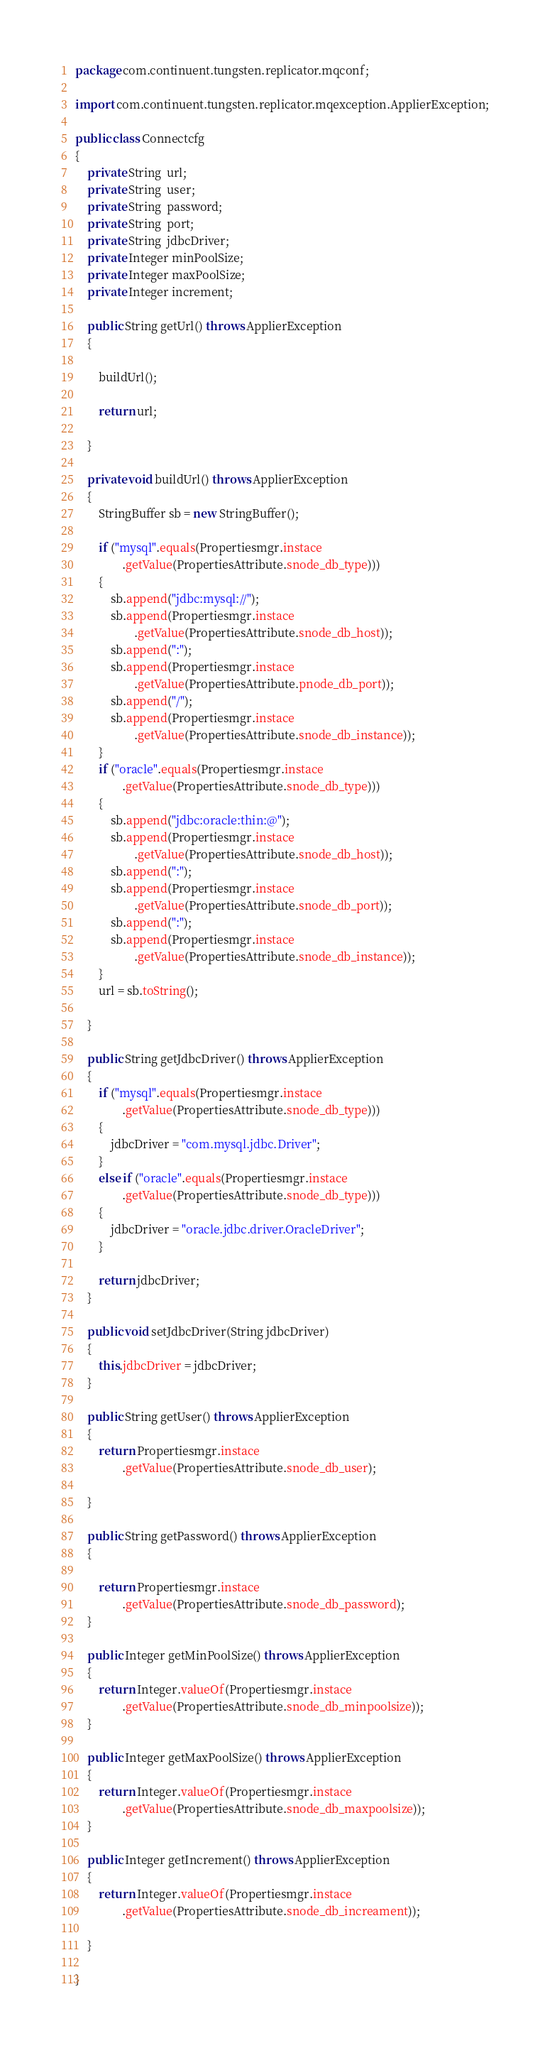Convert code to text. <code><loc_0><loc_0><loc_500><loc_500><_Java_>
package com.continuent.tungsten.replicator.mqconf;

import com.continuent.tungsten.replicator.mqexception.ApplierException;

public class Connectcfg
{
    private String  url;
    private String  user;
    private String  password;
    private String  port;
    private String  jdbcDriver;
    private Integer minPoolSize;
    private Integer maxPoolSize;
    private Integer increment;

    public String getUrl() throws ApplierException
    {

        buildUrl();

        return url;

    }

    private void buildUrl() throws ApplierException
    {
        StringBuffer sb = new StringBuffer();

        if ("mysql".equals(Propertiesmgr.instace
                .getValue(PropertiesAttribute.snode_db_type)))
        {
            sb.append("jdbc:mysql://");
            sb.append(Propertiesmgr.instace
                    .getValue(PropertiesAttribute.snode_db_host));
            sb.append(":");
            sb.append(Propertiesmgr.instace
                    .getValue(PropertiesAttribute.pnode_db_port));
            sb.append("/");
            sb.append(Propertiesmgr.instace
                    .getValue(PropertiesAttribute.snode_db_instance));
        }
        if ("oracle".equals(Propertiesmgr.instace
                .getValue(PropertiesAttribute.snode_db_type)))
        {
            sb.append("jdbc:oracle:thin:@");
            sb.append(Propertiesmgr.instace
                    .getValue(PropertiesAttribute.snode_db_host));
            sb.append(":");
            sb.append(Propertiesmgr.instace
                    .getValue(PropertiesAttribute.snode_db_port));
            sb.append(":");
            sb.append(Propertiesmgr.instace
                    .getValue(PropertiesAttribute.snode_db_instance));
        }
        url = sb.toString();

    }

    public String getJdbcDriver() throws ApplierException
    {
        if ("mysql".equals(Propertiesmgr.instace
                .getValue(PropertiesAttribute.snode_db_type)))
        {
            jdbcDriver = "com.mysql.jdbc.Driver";
        }
        else if ("oracle".equals(Propertiesmgr.instace
                .getValue(PropertiesAttribute.snode_db_type)))
        {
            jdbcDriver = "oracle.jdbc.driver.OracleDriver";
        }

        return jdbcDriver;
    }

    public void setJdbcDriver(String jdbcDriver)
    {
        this.jdbcDriver = jdbcDriver;
    }

    public String getUser() throws ApplierException
    {
        return Propertiesmgr.instace
                .getValue(PropertiesAttribute.snode_db_user);

    }

    public String getPassword() throws ApplierException
    {

        return Propertiesmgr.instace
                .getValue(PropertiesAttribute.snode_db_password);
    }

    public Integer getMinPoolSize() throws ApplierException
    {
        return Integer.valueOf(Propertiesmgr.instace
                .getValue(PropertiesAttribute.snode_db_minpoolsize));
    }

    public Integer getMaxPoolSize() throws ApplierException
    {
        return Integer.valueOf(Propertiesmgr.instace
                .getValue(PropertiesAttribute.snode_db_maxpoolsize));
    }

    public Integer getIncrement() throws ApplierException
    {
        return Integer.valueOf(Propertiesmgr.instace
                .getValue(PropertiesAttribute.snode_db_increament));

    }

}
</code> 